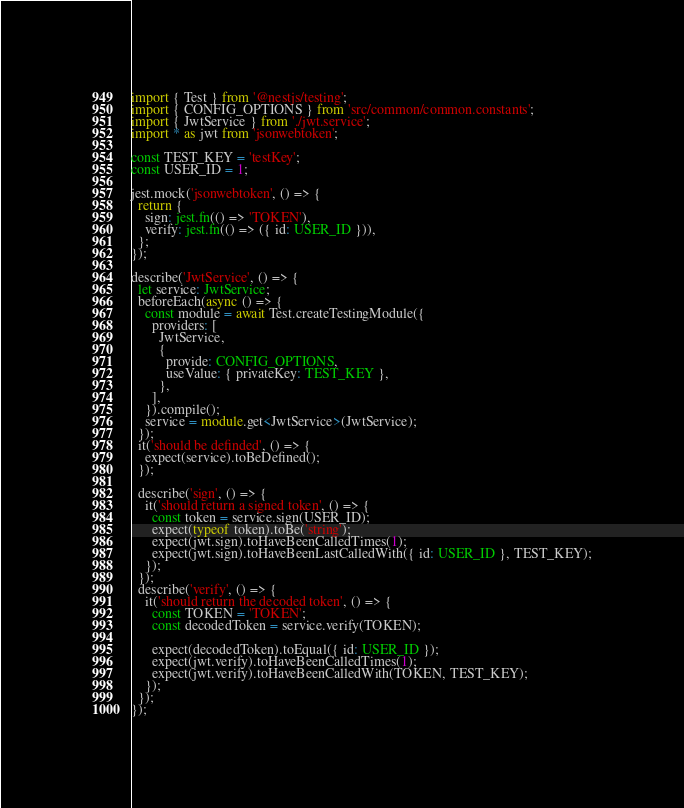Convert code to text. <code><loc_0><loc_0><loc_500><loc_500><_TypeScript_>import { Test } from '@nestjs/testing';
import { CONFIG_OPTIONS } from 'src/common/common.constants';
import { JwtService } from './jwt.service';
import * as jwt from 'jsonwebtoken';

const TEST_KEY = 'testKey';
const USER_ID = 1;

jest.mock('jsonwebtoken', () => {
  return {
    sign: jest.fn(() => 'TOKEN'),
    verify: jest.fn(() => ({ id: USER_ID })),
  };
});

describe('JwtService', () => {
  let service: JwtService;
  beforeEach(async () => {
    const module = await Test.createTestingModule({
      providers: [
        JwtService,
        {
          provide: CONFIG_OPTIONS,
          useValue: { privateKey: TEST_KEY },
        },
      ],
    }).compile();
    service = module.get<JwtService>(JwtService);
  });
  it('should be definded', () => {
    expect(service).toBeDefined();
  });

  describe('sign', () => {
    it('should return a signed token', () => {
      const token = service.sign(USER_ID);
      expect(typeof token).toBe('string');
      expect(jwt.sign).toHaveBeenCalledTimes(1);
      expect(jwt.sign).toHaveBeenLastCalledWith({ id: USER_ID }, TEST_KEY);
    });
  });
  describe('verify', () => {
    it('should return the decoded token', () => {
      const TOKEN = 'TOKEN';
      const decodedToken = service.verify(TOKEN);

      expect(decodedToken).toEqual({ id: USER_ID });
      expect(jwt.verify).toHaveBeenCalledTimes(1);
      expect(jwt.verify).toHaveBeenCalledWith(TOKEN, TEST_KEY);
    });
  });
});
</code> 